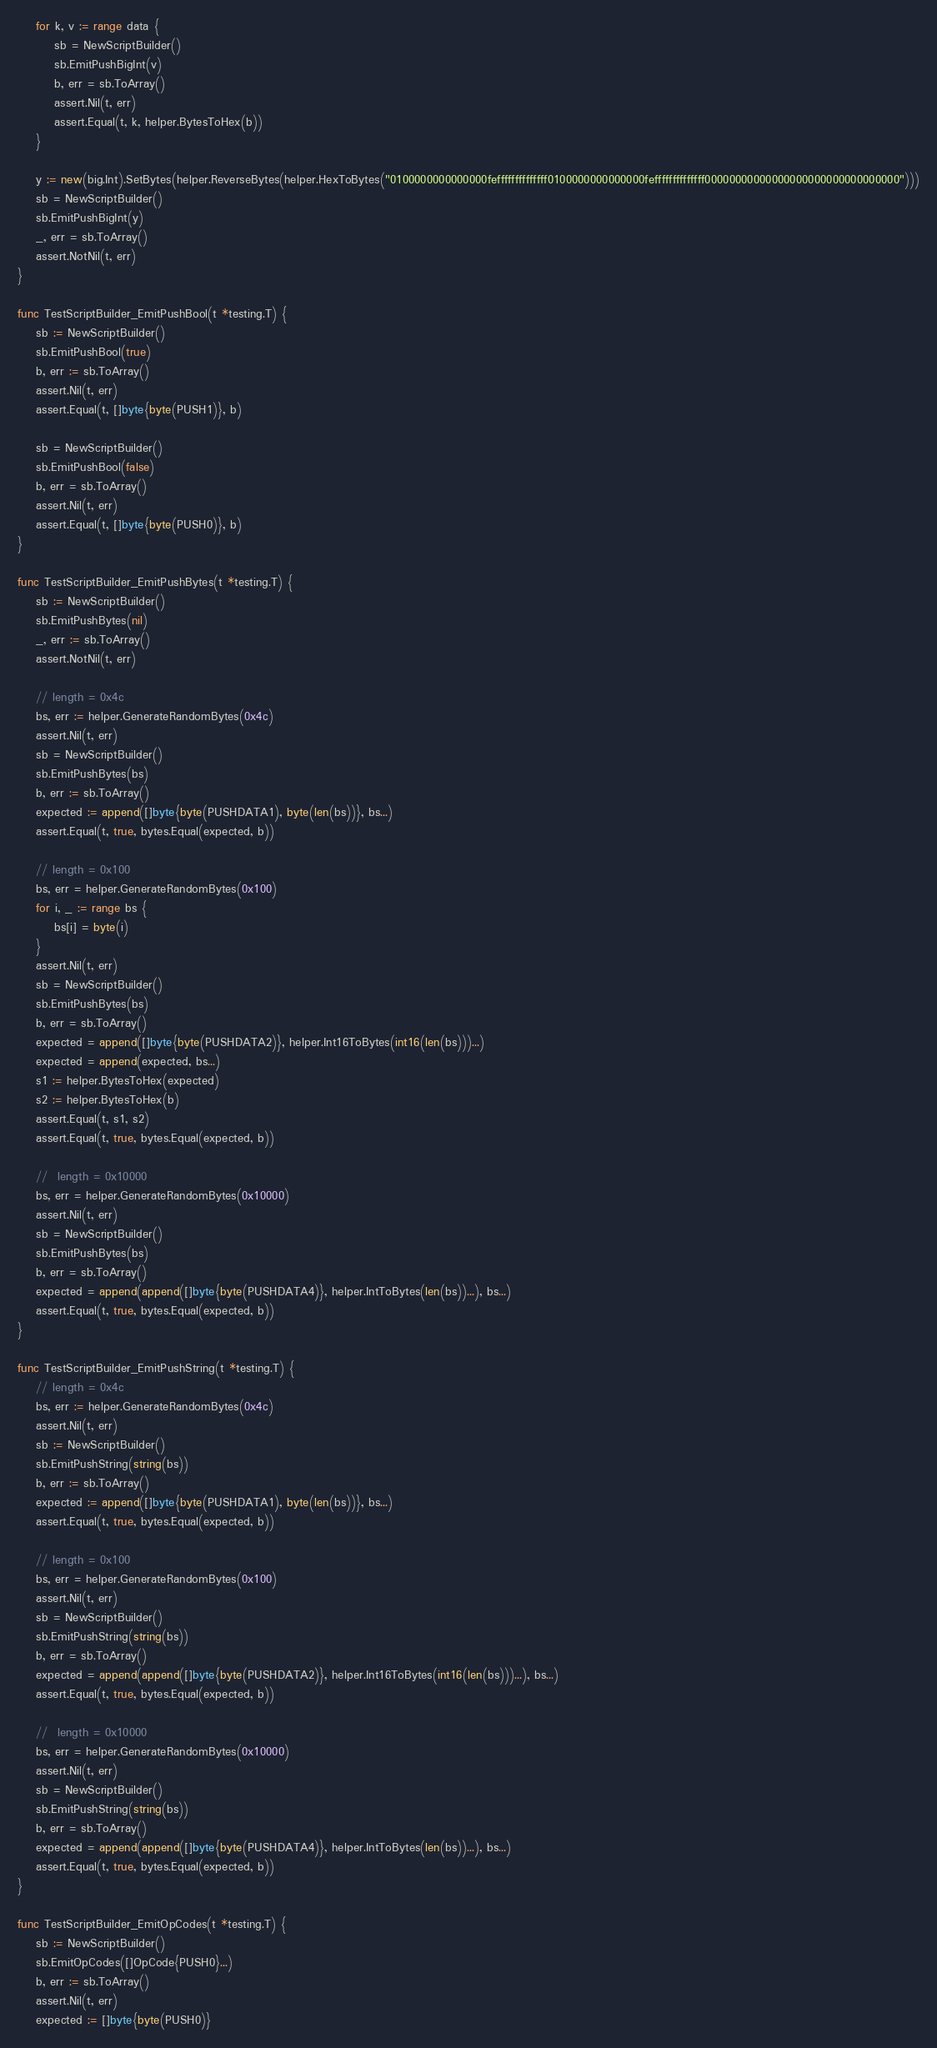Convert code to text. <code><loc_0><loc_0><loc_500><loc_500><_Go_>
	for k, v := range data {
		sb = NewScriptBuilder()
		sb.EmitPushBigInt(v)
		b, err = sb.ToArray()
		assert.Nil(t, err)
		assert.Equal(t, k, helper.BytesToHex(b))
	}

	y := new(big.Int).SetBytes(helper.ReverseBytes(helper.HexToBytes("0100000000000000feffffffffffffff0100000000000000feffffffffffffff00000000000000000000000000000000")))
	sb = NewScriptBuilder()
	sb.EmitPushBigInt(y)
	_, err = sb.ToArray()
	assert.NotNil(t, err)
}

func TestScriptBuilder_EmitPushBool(t *testing.T) {
	sb := NewScriptBuilder()
	sb.EmitPushBool(true)
	b, err := sb.ToArray()
	assert.Nil(t, err)
	assert.Equal(t, []byte{byte(PUSH1)}, b)

	sb = NewScriptBuilder()
	sb.EmitPushBool(false)
	b, err = sb.ToArray()
	assert.Nil(t, err)
	assert.Equal(t, []byte{byte(PUSH0)}, b)
}

func TestScriptBuilder_EmitPushBytes(t *testing.T) {
	sb := NewScriptBuilder()
	sb.EmitPushBytes(nil)
	_, err := sb.ToArray()
	assert.NotNil(t, err)

	// length = 0x4c
	bs, err := helper.GenerateRandomBytes(0x4c)
	assert.Nil(t, err)
	sb = NewScriptBuilder()
	sb.EmitPushBytes(bs)
	b, err := sb.ToArray()
	expected := append([]byte{byte(PUSHDATA1), byte(len(bs))}, bs...)
	assert.Equal(t, true, bytes.Equal(expected, b))

	// length = 0x100
	bs, err = helper.GenerateRandomBytes(0x100)
	for i, _ := range bs {
		bs[i] = byte(i)
	}
	assert.Nil(t, err)
	sb = NewScriptBuilder()
	sb.EmitPushBytes(bs)
	b, err = sb.ToArray()
	expected = append([]byte{byte(PUSHDATA2)}, helper.Int16ToBytes(int16(len(bs)))...)
	expected = append(expected, bs...)
	s1 := helper.BytesToHex(expected)
	s2 := helper.BytesToHex(b)
	assert.Equal(t, s1, s2)
	assert.Equal(t, true, bytes.Equal(expected, b))

	//  length = 0x10000
	bs, err = helper.GenerateRandomBytes(0x10000)
	assert.Nil(t, err)
	sb = NewScriptBuilder()
	sb.EmitPushBytes(bs)
	b, err = sb.ToArray()
	expected = append(append([]byte{byte(PUSHDATA4)}, helper.IntToBytes(len(bs))...), bs...)
	assert.Equal(t, true, bytes.Equal(expected, b))
}

func TestScriptBuilder_EmitPushString(t *testing.T) {
	// length = 0x4c
	bs, err := helper.GenerateRandomBytes(0x4c)
	assert.Nil(t, err)
	sb := NewScriptBuilder()
	sb.EmitPushString(string(bs))
	b, err := sb.ToArray()
	expected := append([]byte{byte(PUSHDATA1), byte(len(bs))}, bs...)
	assert.Equal(t, true, bytes.Equal(expected, b))

	// length = 0x100
	bs, err = helper.GenerateRandomBytes(0x100)
	assert.Nil(t, err)
	sb = NewScriptBuilder()
	sb.EmitPushString(string(bs))
	b, err = sb.ToArray()
	expected = append(append([]byte{byte(PUSHDATA2)}, helper.Int16ToBytes(int16(len(bs)))...), bs...)
	assert.Equal(t, true, bytes.Equal(expected, b))

	//  length = 0x10000
	bs, err = helper.GenerateRandomBytes(0x10000)
	assert.Nil(t, err)
	sb = NewScriptBuilder()
	sb.EmitPushString(string(bs))
	b, err = sb.ToArray()
	expected = append(append([]byte{byte(PUSHDATA4)}, helper.IntToBytes(len(bs))...), bs...)
	assert.Equal(t, true, bytes.Equal(expected, b))
}

func TestScriptBuilder_EmitOpCodes(t *testing.T) {
	sb := NewScriptBuilder()
	sb.EmitOpCodes([]OpCode{PUSH0}...)
	b, err := sb.ToArray()
	assert.Nil(t, err)
	expected := []byte{byte(PUSH0)}</code> 